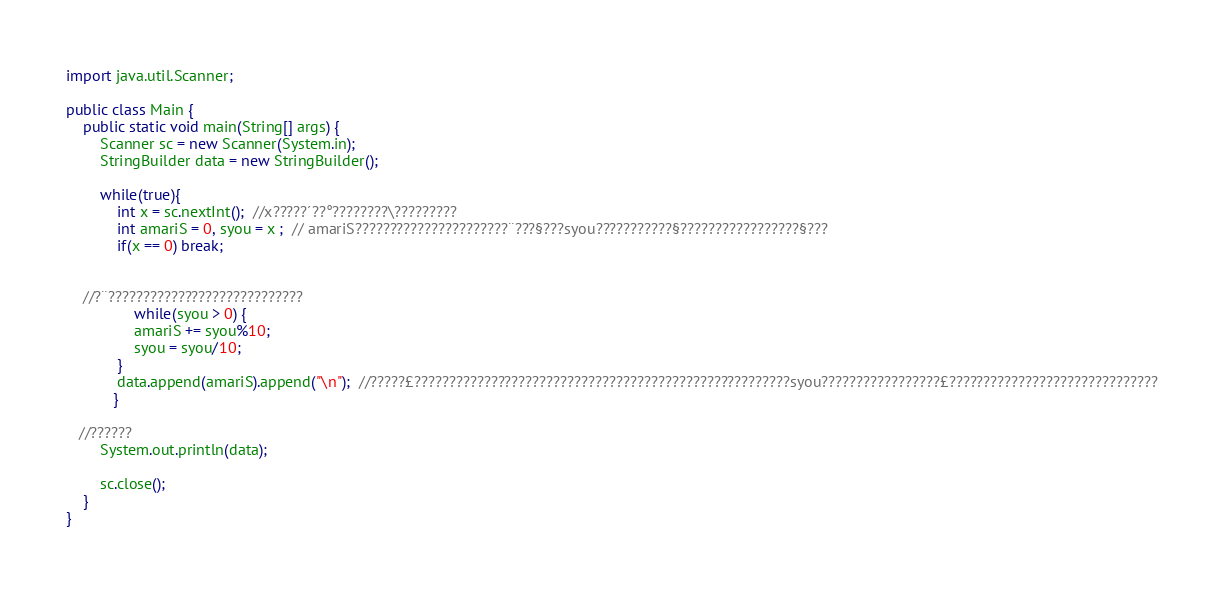<code> <loc_0><loc_0><loc_500><loc_500><_Java_>import java.util.Scanner;

public class Main {
	public static void main(String[] args) {
		Scanner sc = new Scanner(System.in);
		StringBuilder data = new StringBuilder();
		
		while(true){
			int x = sc.nextInt();  //x?????´??°????????\?????????
			int amariS = 0, syou = x ;  // amariS??????????????????????¨???§???syou???????????§?????????????????§???
			if(x == 0) break;
			
		
	//?¨????????????????????????????
				while(syou > 0) {
				amariS += syou%10;
				syou = syou/10;
			}
			data.append(amariS).append("\n");  //?????£??????????????????????????????????????????????????????syou?????????????????£??????????????????????????????
		   }
		
   //??????
		System.out.println(data);
		
		sc.close();
	}
}</code> 